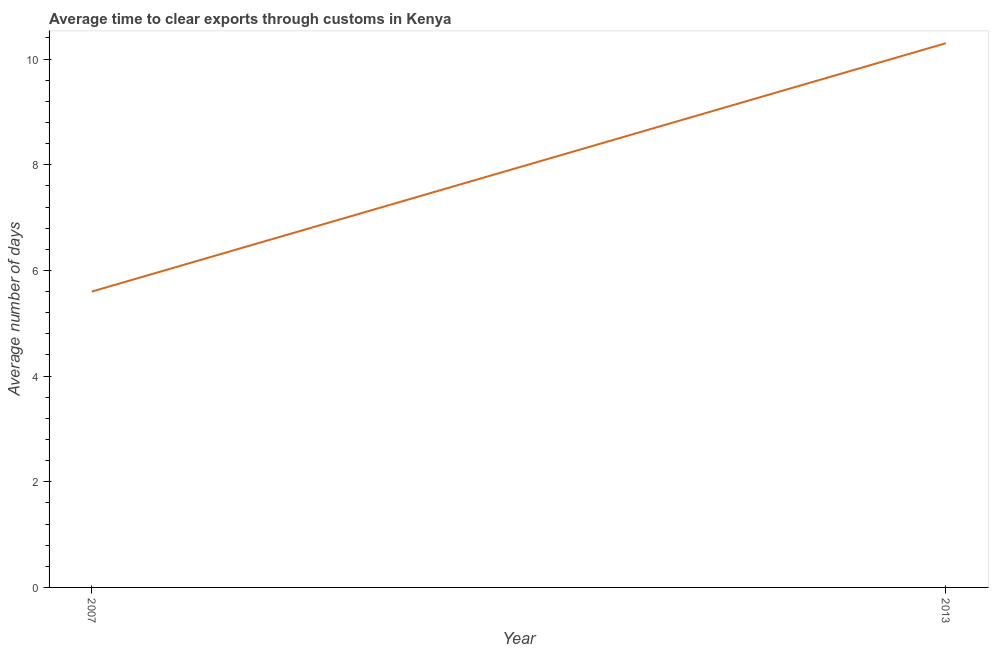In which year was the time to clear exports through customs maximum?
Give a very brief answer. 2013. What is the sum of the time to clear exports through customs?
Your answer should be compact. 15.9. What is the difference between the time to clear exports through customs in 2007 and 2013?
Your response must be concise. -4.7. What is the average time to clear exports through customs per year?
Make the answer very short. 7.95. What is the median time to clear exports through customs?
Offer a very short reply. 7.95. In how many years, is the time to clear exports through customs greater than 0.4 days?
Your answer should be very brief. 2. What is the ratio of the time to clear exports through customs in 2007 to that in 2013?
Your answer should be very brief. 0.54. Is the time to clear exports through customs in 2007 less than that in 2013?
Offer a terse response. Yes. Does the time to clear exports through customs monotonically increase over the years?
Your response must be concise. Yes. How many lines are there?
Your answer should be very brief. 1. How many years are there in the graph?
Provide a short and direct response. 2. What is the difference between two consecutive major ticks on the Y-axis?
Ensure brevity in your answer.  2. Does the graph contain any zero values?
Ensure brevity in your answer.  No. Does the graph contain grids?
Give a very brief answer. No. What is the title of the graph?
Your answer should be very brief. Average time to clear exports through customs in Kenya. What is the label or title of the X-axis?
Provide a succinct answer. Year. What is the label or title of the Y-axis?
Your answer should be compact. Average number of days. What is the Average number of days in 2007?
Your response must be concise. 5.6. What is the Average number of days of 2013?
Your answer should be compact. 10.3. What is the difference between the Average number of days in 2007 and 2013?
Offer a very short reply. -4.7. What is the ratio of the Average number of days in 2007 to that in 2013?
Ensure brevity in your answer.  0.54. 